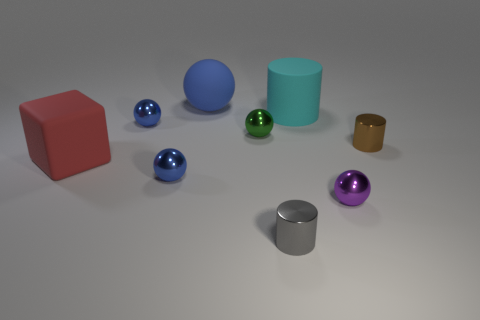Is the number of things that are in front of the purple shiny sphere less than the number of large matte cylinders?
Keep it short and to the point. No. Are there any other things that have the same shape as the red rubber thing?
Keep it short and to the point. No. There is another big thing that is the same shape as the gray object; what color is it?
Your answer should be compact. Cyan. Do the thing in front of the purple shiny thing and the purple object have the same size?
Your answer should be compact. Yes. There is a matte sphere on the right side of the blue shiny sphere behind the big rubber block; how big is it?
Offer a very short reply. Large. Is the tiny gray cylinder made of the same material as the tiny blue ball behind the large block?
Keep it short and to the point. Yes. Are there fewer small shiny balls that are behind the rubber sphere than big balls that are behind the rubber cylinder?
Keep it short and to the point. Yes. There is a large cylinder that is made of the same material as the big blue thing; what is its color?
Your answer should be very brief. Cyan. There is a big thing left of the large blue sphere; is there a shiny object right of it?
Your answer should be very brief. Yes. There is a matte cylinder that is the same size as the matte ball; what is its color?
Provide a short and direct response. Cyan. 